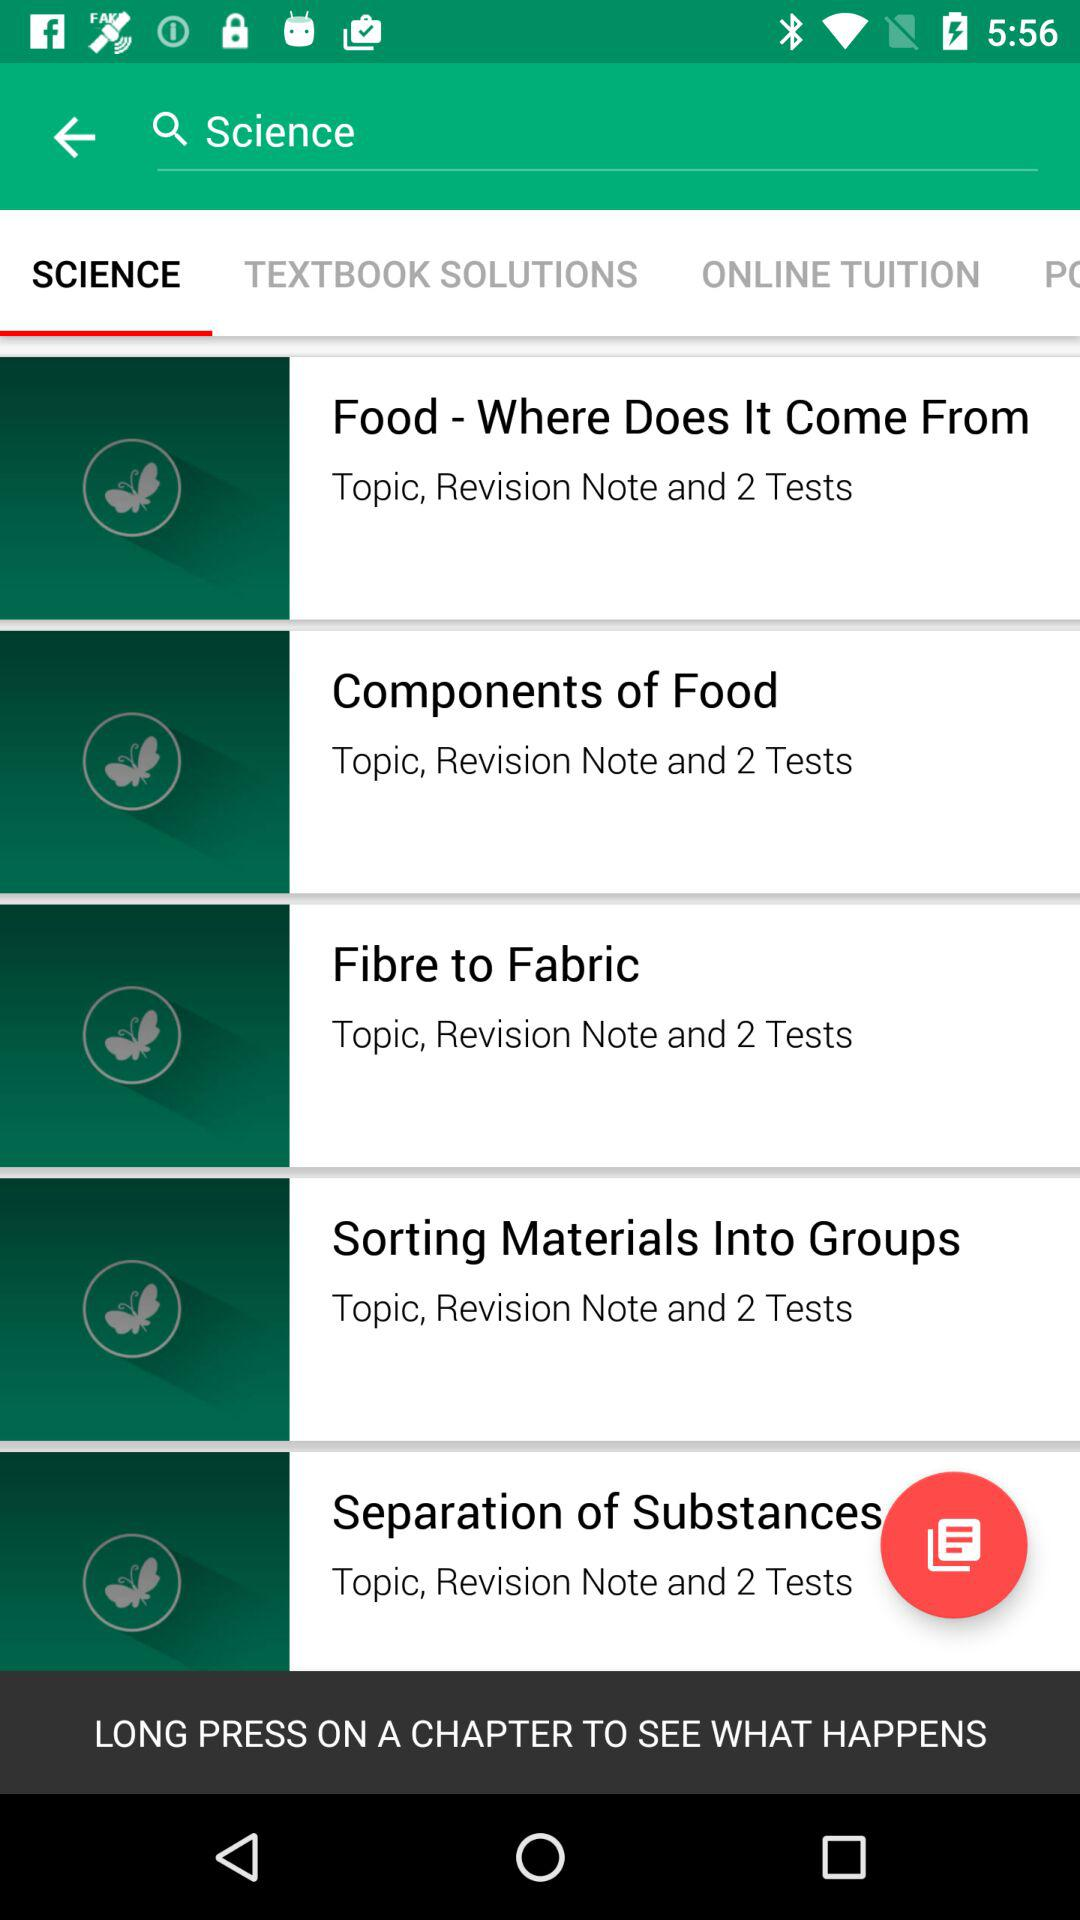How many chapters are there in total?
Answer the question using a single word or phrase. 5 